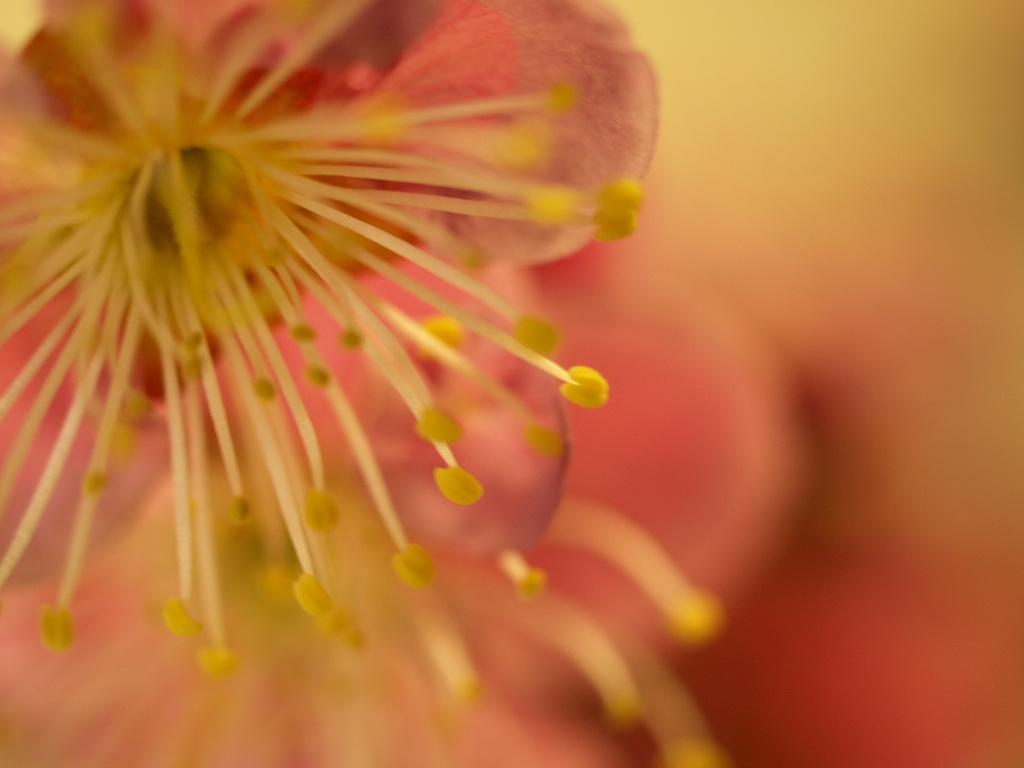What is the main subject in the center of the image? There is a flower in the center of the image. Can you describe the background of the image? The background of the image is blurry. What type of coal is being mined in the background of the image? There is no coal or mining activity present in the image; it features a flower in the center and a blurry background. 